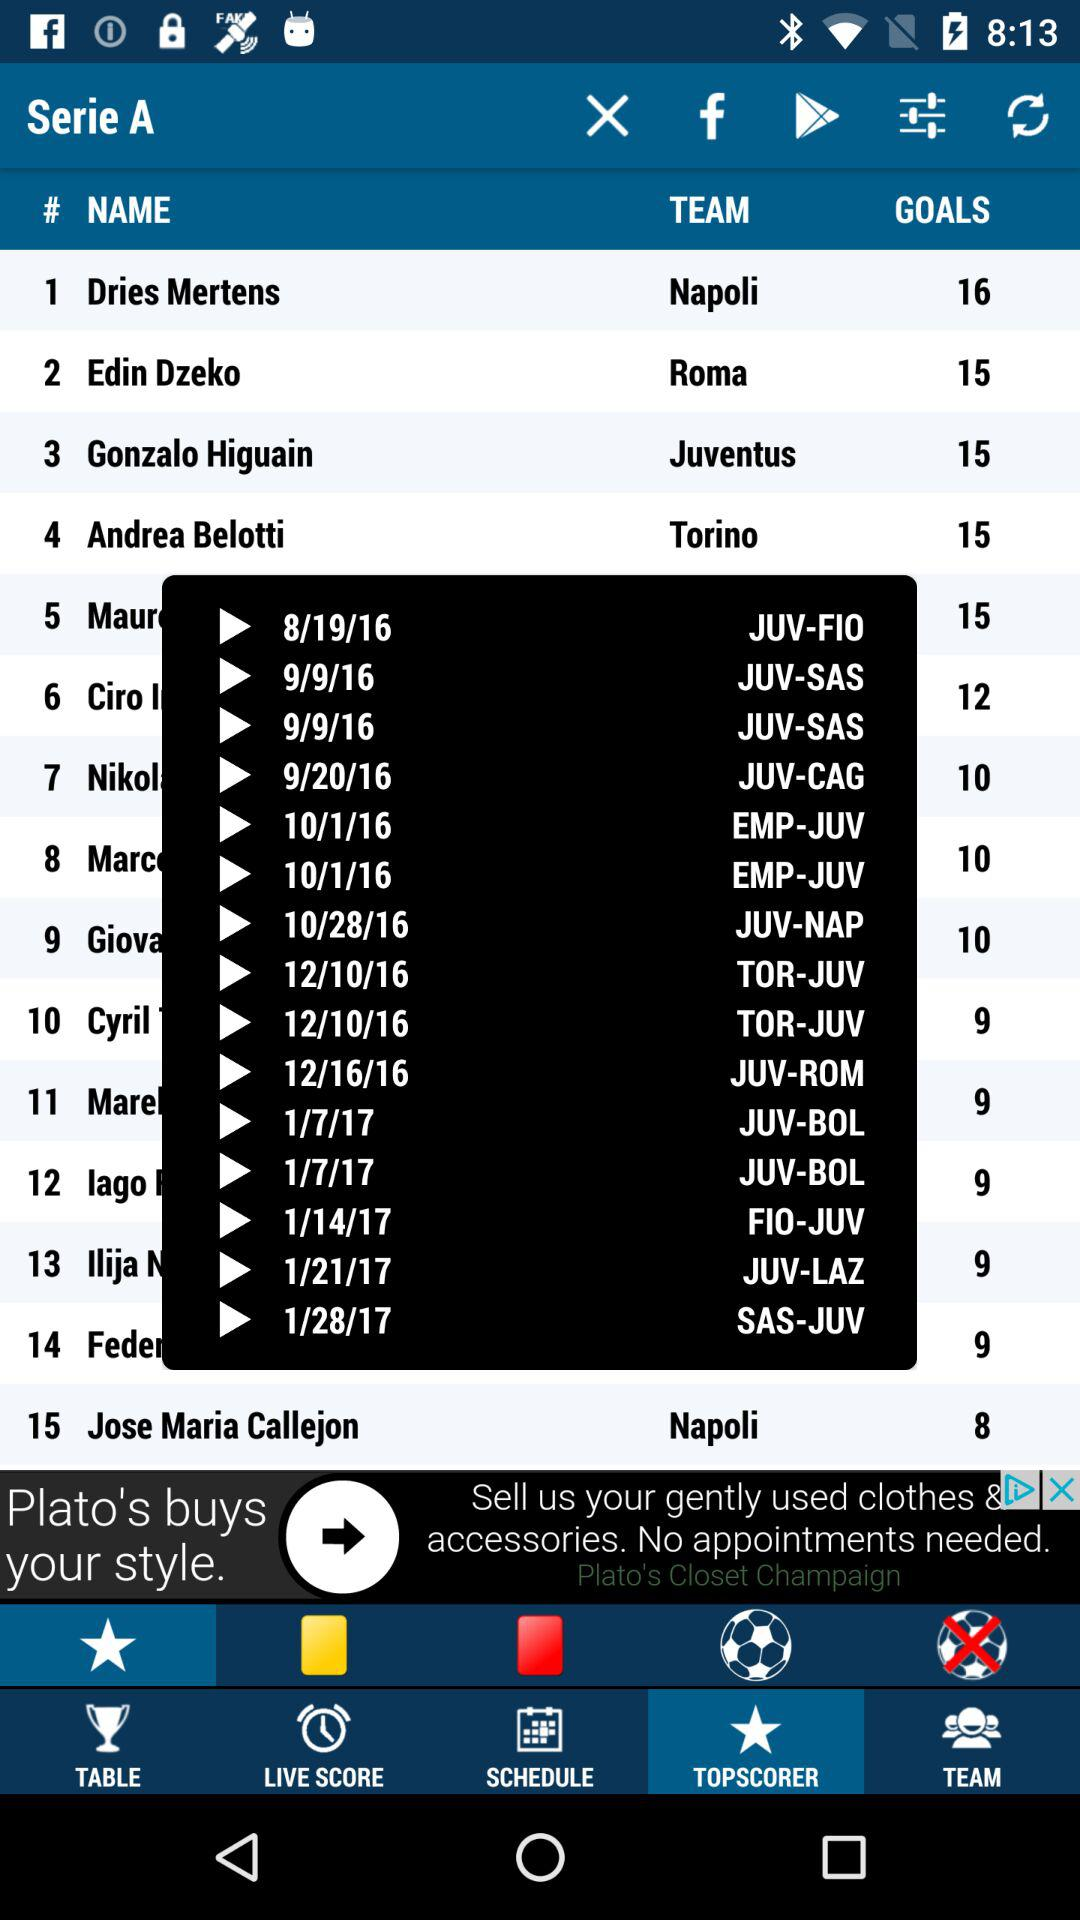What is the number of goals scored by Andrea Belotti? The number of goals scored by Andrea Belotti is 15. 